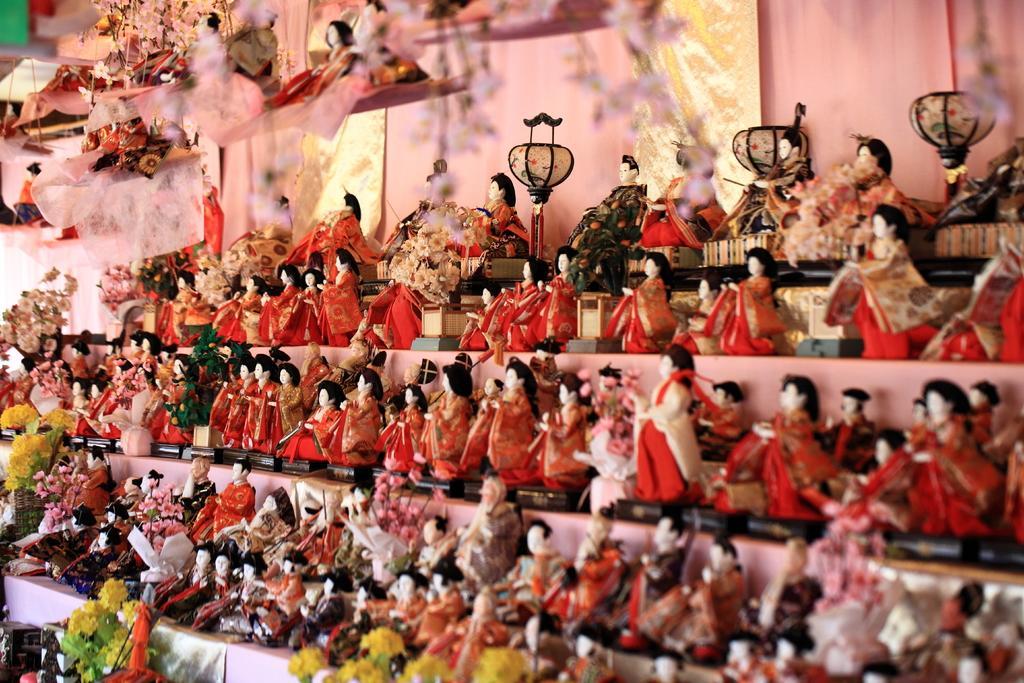Could you give a brief overview of what you see in this image? In this picture I can see a bunch of toys and few flowers to the toys and few toys are hanging. 